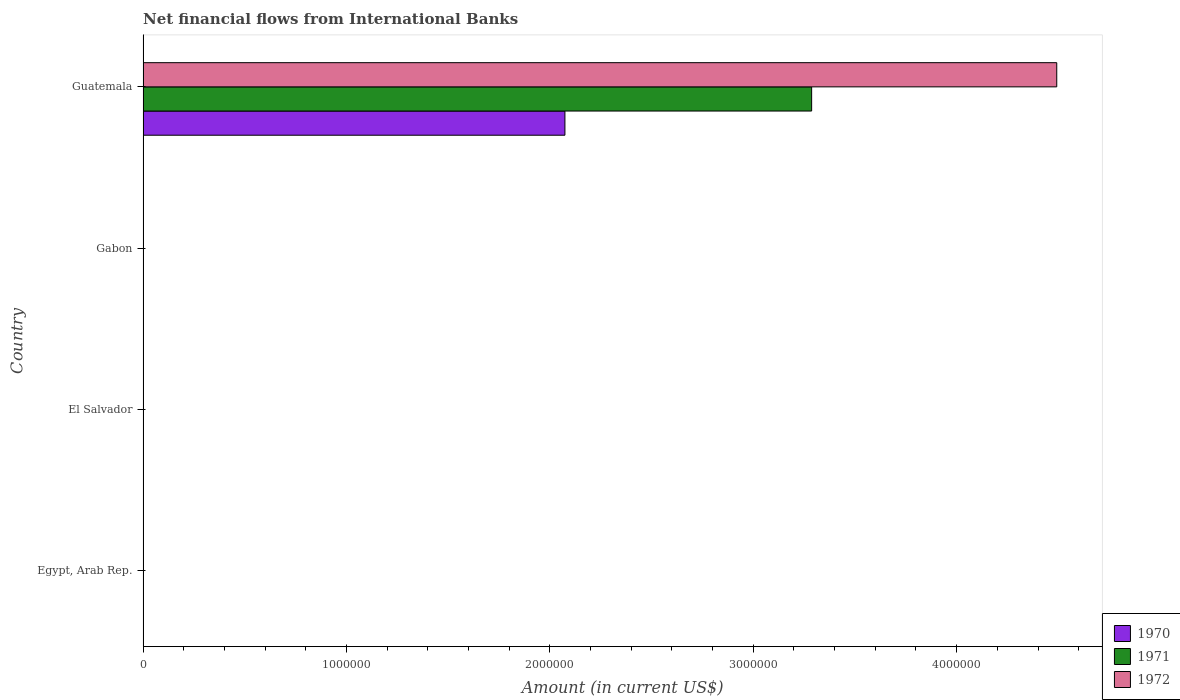Are the number of bars per tick equal to the number of legend labels?
Provide a short and direct response. No. How many bars are there on the 2nd tick from the top?
Provide a succinct answer. 0. What is the label of the 1st group of bars from the top?
Your answer should be very brief. Guatemala. Across all countries, what is the maximum net financial aid flows in 1971?
Make the answer very short. 3.29e+06. In which country was the net financial aid flows in 1970 maximum?
Your answer should be very brief. Guatemala. What is the total net financial aid flows in 1971 in the graph?
Your response must be concise. 3.29e+06. What is the difference between the net financial aid flows in 1970 in Guatemala and the net financial aid flows in 1971 in Gabon?
Make the answer very short. 2.07e+06. What is the average net financial aid flows in 1972 per country?
Provide a short and direct response. 1.12e+06. What is the difference between the net financial aid flows in 1972 and net financial aid flows in 1971 in Guatemala?
Ensure brevity in your answer.  1.20e+06. In how many countries, is the net financial aid flows in 1972 greater than 4200000 US$?
Give a very brief answer. 1. What is the difference between the highest and the lowest net financial aid flows in 1972?
Offer a terse response. 4.49e+06. Is it the case that in every country, the sum of the net financial aid flows in 1971 and net financial aid flows in 1970 is greater than the net financial aid flows in 1972?
Give a very brief answer. No. How many bars are there?
Your answer should be compact. 3. Are all the bars in the graph horizontal?
Make the answer very short. Yes. How many countries are there in the graph?
Your answer should be very brief. 4. What is the difference between two consecutive major ticks on the X-axis?
Offer a terse response. 1.00e+06. Are the values on the major ticks of X-axis written in scientific E-notation?
Make the answer very short. No. Does the graph contain grids?
Your response must be concise. No. Where does the legend appear in the graph?
Offer a very short reply. Bottom right. How are the legend labels stacked?
Provide a short and direct response. Vertical. What is the title of the graph?
Offer a terse response. Net financial flows from International Banks. Does "1975" appear as one of the legend labels in the graph?
Give a very brief answer. No. What is the label or title of the Y-axis?
Offer a very short reply. Country. What is the Amount (in current US$) in 1970 in El Salvador?
Your answer should be very brief. 0. What is the Amount (in current US$) in 1971 in El Salvador?
Provide a short and direct response. 0. What is the Amount (in current US$) in 1972 in El Salvador?
Your answer should be compact. 0. What is the Amount (in current US$) in 1970 in Gabon?
Make the answer very short. 0. What is the Amount (in current US$) of 1971 in Gabon?
Offer a very short reply. 0. What is the Amount (in current US$) in 1970 in Guatemala?
Ensure brevity in your answer.  2.07e+06. What is the Amount (in current US$) in 1971 in Guatemala?
Keep it short and to the point. 3.29e+06. What is the Amount (in current US$) of 1972 in Guatemala?
Your answer should be very brief. 4.49e+06. Across all countries, what is the maximum Amount (in current US$) of 1970?
Offer a terse response. 2.07e+06. Across all countries, what is the maximum Amount (in current US$) in 1971?
Your response must be concise. 3.29e+06. Across all countries, what is the maximum Amount (in current US$) of 1972?
Your answer should be very brief. 4.49e+06. Across all countries, what is the minimum Amount (in current US$) of 1971?
Offer a very short reply. 0. Across all countries, what is the minimum Amount (in current US$) in 1972?
Provide a short and direct response. 0. What is the total Amount (in current US$) in 1970 in the graph?
Offer a very short reply. 2.07e+06. What is the total Amount (in current US$) of 1971 in the graph?
Your answer should be compact. 3.29e+06. What is the total Amount (in current US$) of 1972 in the graph?
Make the answer very short. 4.49e+06. What is the average Amount (in current US$) in 1970 per country?
Provide a succinct answer. 5.18e+05. What is the average Amount (in current US$) in 1971 per country?
Keep it short and to the point. 8.22e+05. What is the average Amount (in current US$) of 1972 per country?
Your response must be concise. 1.12e+06. What is the difference between the Amount (in current US$) of 1970 and Amount (in current US$) of 1971 in Guatemala?
Offer a terse response. -1.21e+06. What is the difference between the Amount (in current US$) in 1970 and Amount (in current US$) in 1972 in Guatemala?
Your answer should be very brief. -2.42e+06. What is the difference between the Amount (in current US$) of 1971 and Amount (in current US$) of 1972 in Guatemala?
Give a very brief answer. -1.20e+06. What is the difference between the highest and the lowest Amount (in current US$) in 1970?
Your answer should be very brief. 2.07e+06. What is the difference between the highest and the lowest Amount (in current US$) of 1971?
Provide a succinct answer. 3.29e+06. What is the difference between the highest and the lowest Amount (in current US$) of 1972?
Ensure brevity in your answer.  4.49e+06. 